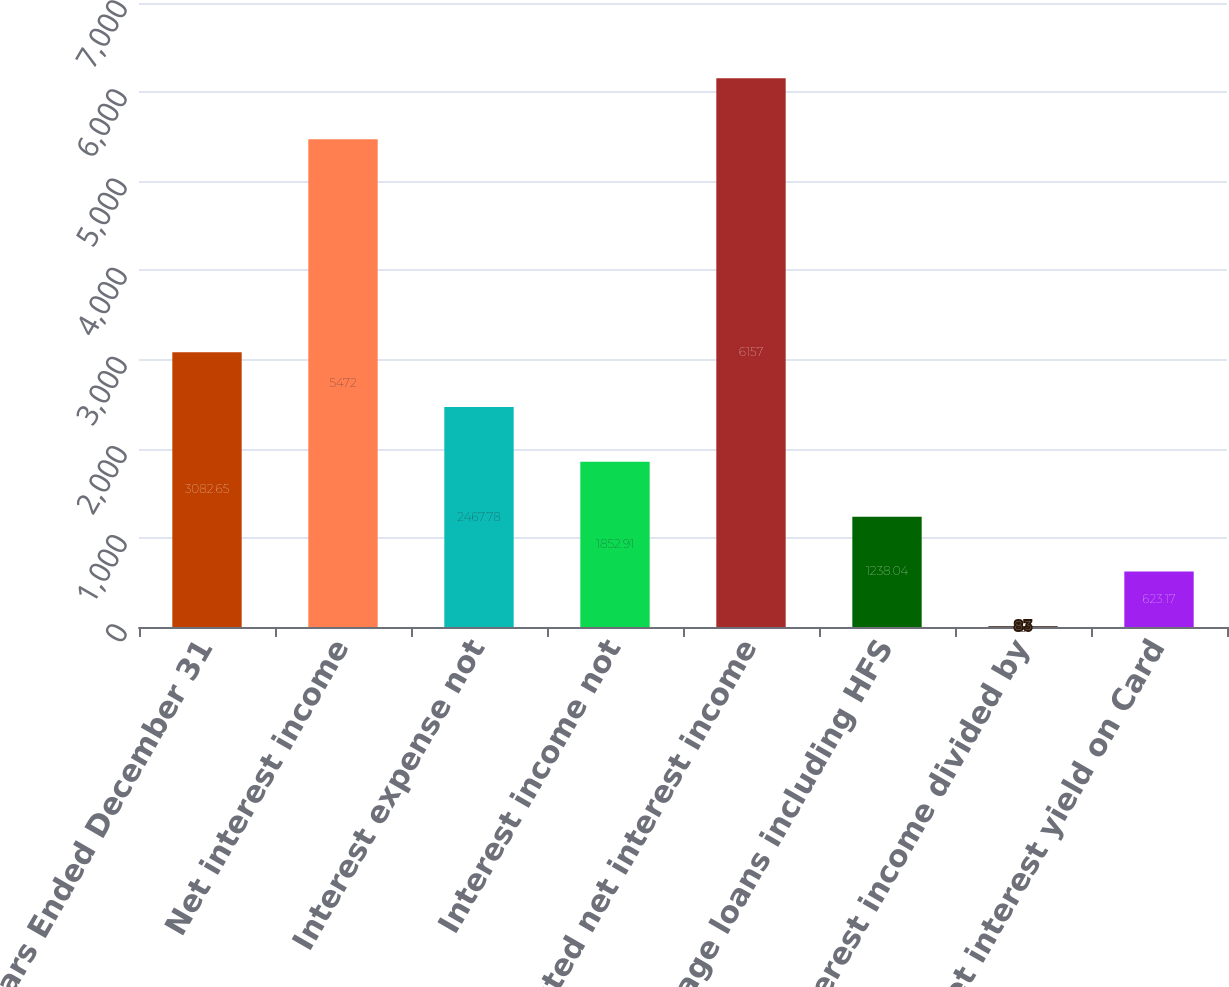<chart> <loc_0><loc_0><loc_500><loc_500><bar_chart><fcel>Years Ended December 31<fcel>Net interest income<fcel>Interest expense not<fcel>Interest income not<fcel>Adjusted net interest income<fcel>Average loans including HFS<fcel>Net interest income divided by<fcel>Net interest yield on Card<nl><fcel>3082.65<fcel>5472<fcel>2467.78<fcel>1852.91<fcel>6157<fcel>1238.04<fcel>8.3<fcel>623.17<nl></chart> 